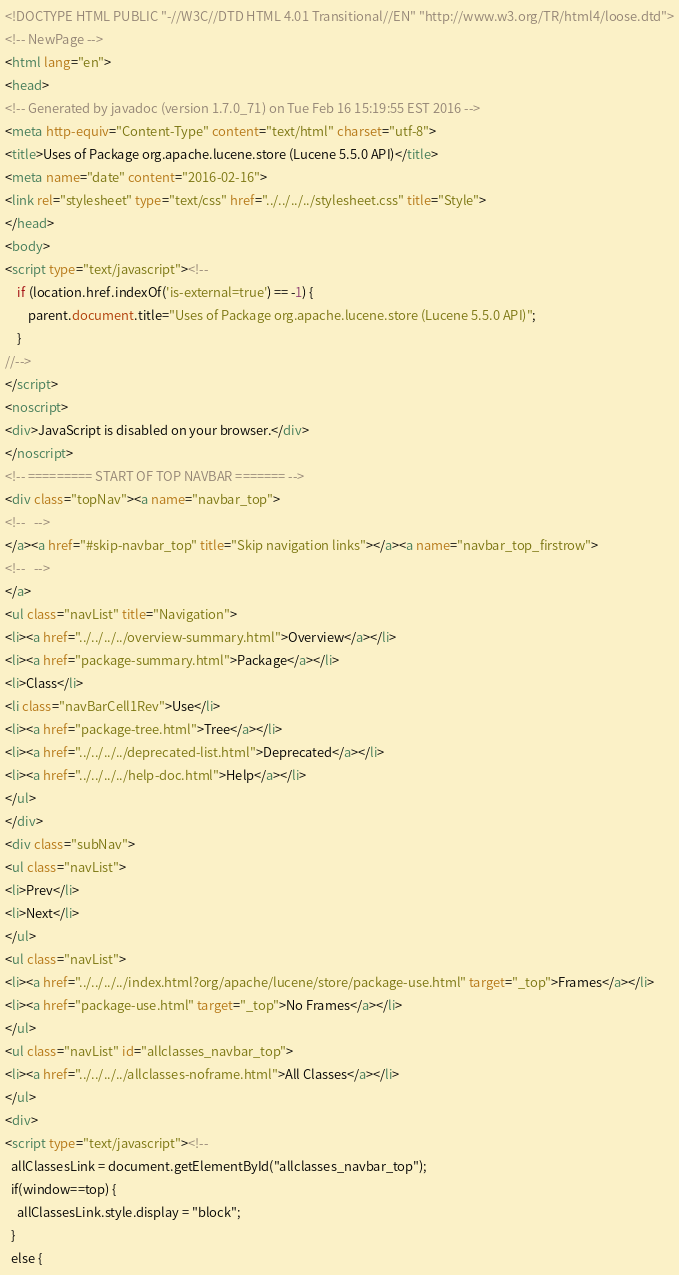Convert code to text. <code><loc_0><loc_0><loc_500><loc_500><_HTML_><!DOCTYPE HTML PUBLIC "-//W3C//DTD HTML 4.01 Transitional//EN" "http://www.w3.org/TR/html4/loose.dtd">
<!-- NewPage -->
<html lang="en">
<head>
<!-- Generated by javadoc (version 1.7.0_71) on Tue Feb 16 15:19:55 EST 2016 -->
<meta http-equiv="Content-Type" content="text/html" charset="utf-8">
<title>Uses of Package org.apache.lucene.store (Lucene 5.5.0 API)</title>
<meta name="date" content="2016-02-16">
<link rel="stylesheet" type="text/css" href="../../../../stylesheet.css" title="Style">
</head>
<body>
<script type="text/javascript"><!--
    if (location.href.indexOf('is-external=true') == -1) {
        parent.document.title="Uses of Package org.apache.lucene.store (Lucene 5.5.0 API)";
    }
//-->
</script>
<noscript>
<div>JavaScript is disabled on your browser.</div>
</noscript>
<!-- ========= START OF TOP NAVBAR ======= -->
<div class="topNav"><a name="navbar_top">
<!--   -->
</a><a href="#skip-navbar_top" title="Skip navigation links"></a><a name="navbar_top_firstrow">
<!--   -->
</a>
<ul class="navList" title="Navigation">
<li><a href="../../../../overview-summary.html">Overview</a></li>
<li><a href="package-summary.html">Package</a></li>
<li>Class</li>
<li class="navBarCell1Rev">Use</li>
<li><a href="package-tree.html">Tree</a></li>
<li><a href="../../../../deprecated-list.html">Deprecated</a></li>
<li><a href="../../../../help-doc.html">Help</a></li>
</ul>
</div>
<div class="subNav">
<ul class="navList">
<li>Prev</li>
<li>Next</li>
</ul>
<ul class="navList">
<li><a href="../../../../index.html?org/apache/lucene/store/package-use.html" target="_top">Frames</a></li>
<li><a href="package-use.html" target="_top">No Frames</a></li>
</ul>
<ul class="navList" id="allclasses_navbar_top">
<li><a href="../../../../allclasses-noframe.html">All Classes</a></li>
</ul>
<div>
<script type="text/javascript"><!--
  allClassesLink = document.getElementById("allclasses_navbar_top");
  if(window==top) {
    allClassesLink.style.display = "block";
  }
  else {</code> 